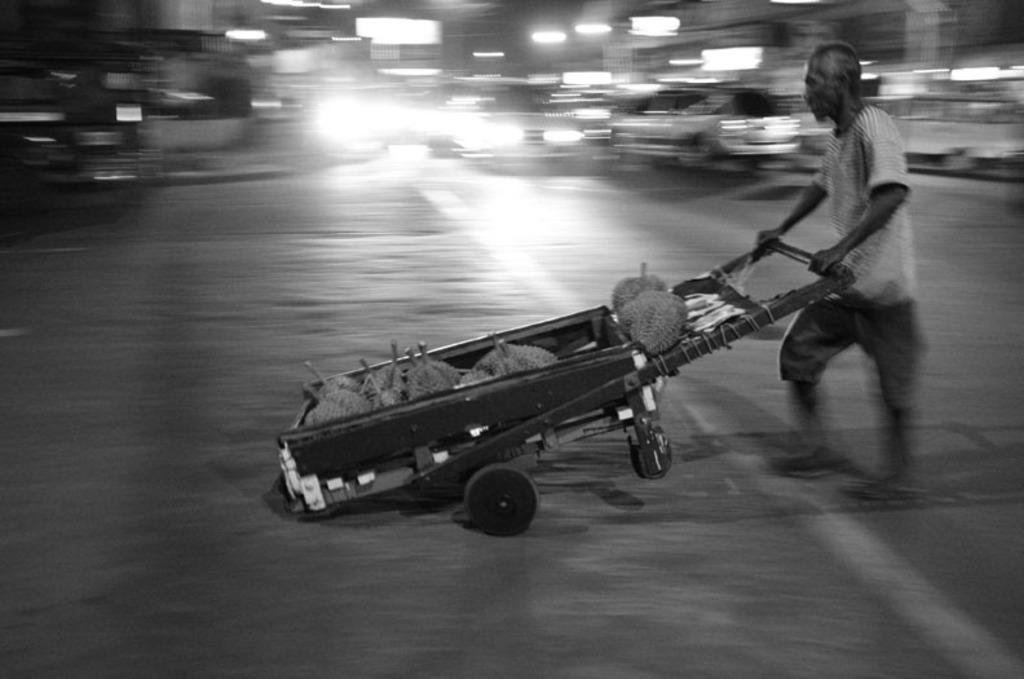Who is the main subject in the image? There is a man in the image. What is the man doing in the image? The man is pushing a cart and walking. Where are the man and the cart located in the image? The man and the cart are on the right side of the image. What type of produce can be seen growing on the earth in the image? There is no produce or earth visible in the image; it features a man pushing a cart and walking. 